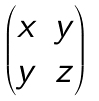<formula> <loc_0><loc_0><loc_500><loc_500>\begin{pmatrix} x & y \\ y & z \end{pmatrix}</formula> 